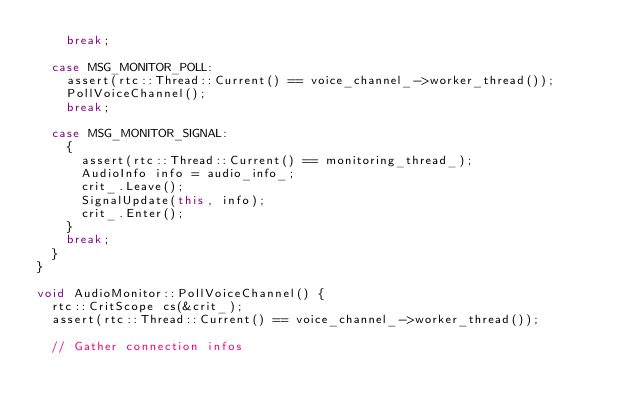<code> <loc_0><loc_0><loc_500><loc_500><_C++_>    break;

  case MSG_MONITOR_POLL:
    assert(rtc::Thread::Current() == voice_channel_->worker_thread());
    PollVoiceChannel();
    break;

  case MSG_MONITOR_SIGNAL:
    {
      assert(rtc::Thread::Current() == monitoring_thread_);
      AudioInfo info = audio_info_;
      crit_.Leave();
      SignalUpdate(this, info);
      crit_.Enter();
    }
    break;
  }
}

void AudioMonitor::PollVoiceChannel() {
  rtc::CritScope cs(&crit_);
  assert(rtc::Thread::Current() == voice_channel_->worker_thread());

  // Gather connection infos</code> 